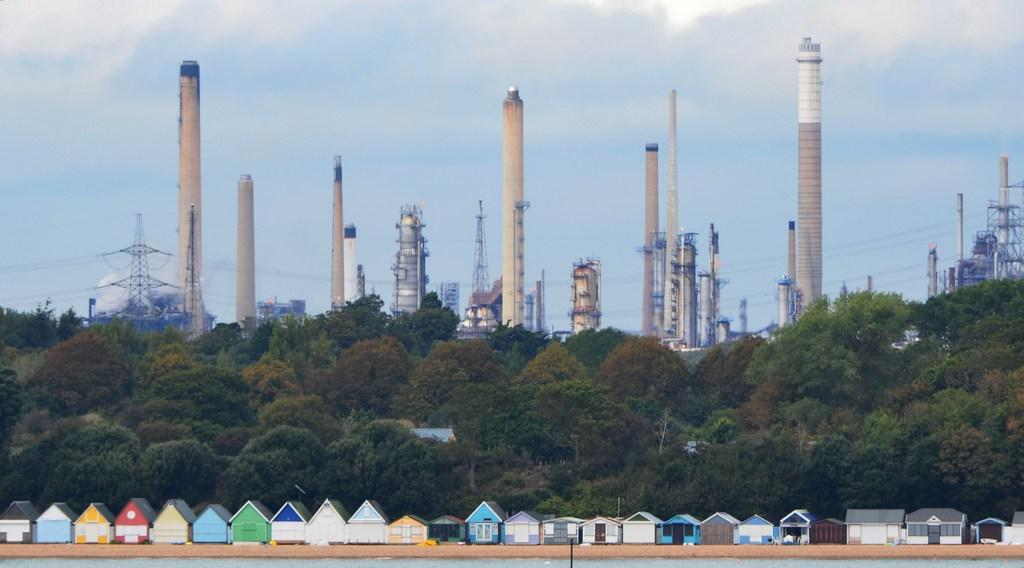What type of structures can be seen in the image? There are chimneys, towers, buildings, and sheds in the image. What type of vegetation is present in the image? There are trees in the image. What can be seen in the sky in the image? There are clouds in the sky in the image. What is visible at the bottom of the image? There is water visible at the bottom of the image. Can you describe the behavior of the goldfish in the image? There are no goldfish present in the image. What type of sand can be seen in the image? There is no sand visible in the image. 